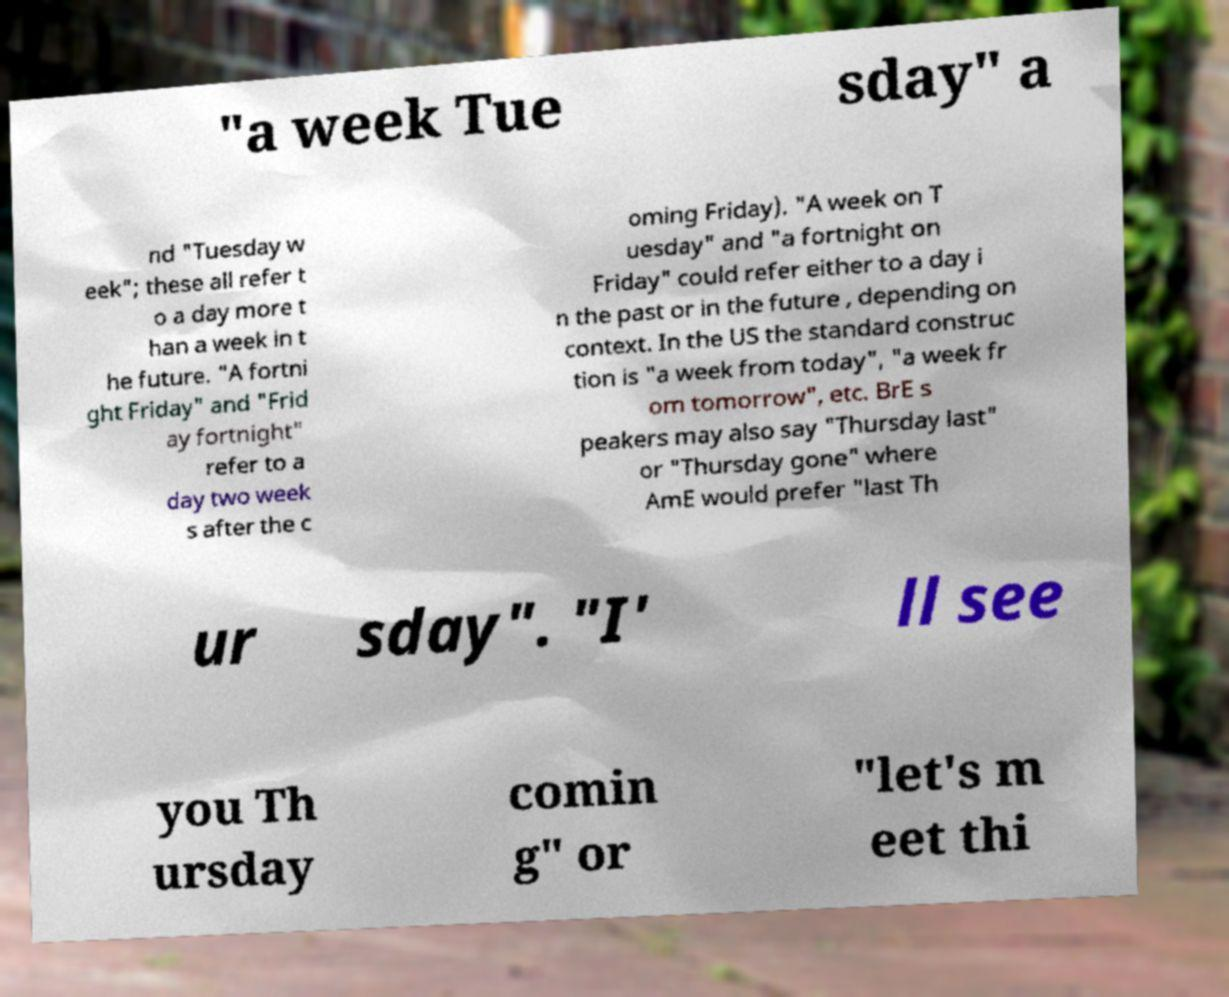Can you accurately transcribe the text from the provided image for me? "a week Tue sday" a nd "Tuesday w eek"; these all refer t o a day more t han a week in t he future. "A fortni ght Friday" and "Frid ay fortnight" refer to a day two week s after the c oming Friday). "A week on T uesday" and "a fortnight on Friday" could refer either to a day i n the past or in the future , depending on context. In the US the standard construc tion is "a week from today", "a week fr om tomorrow", etc. BrE s peakers may also say "Thursday last" or "Thursday gone" where AmE would prefer "last Th ur sday". "I' ll see you Th ursday comin g" or "let's m eet thi 